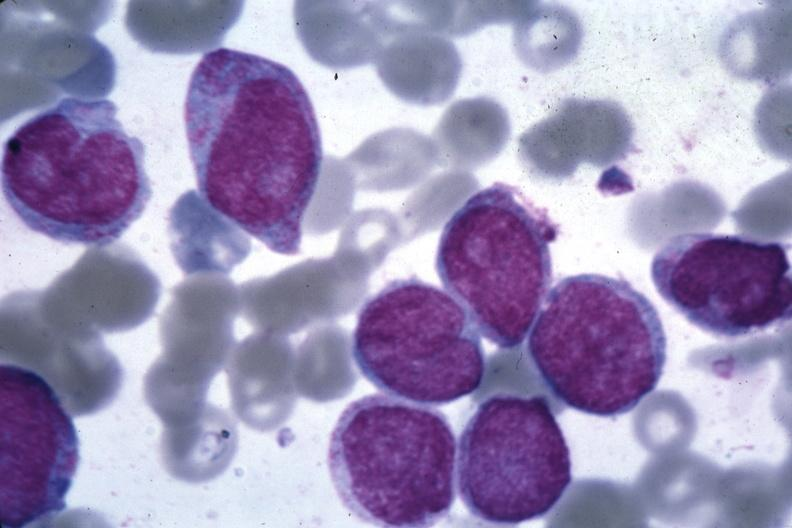what is present?
Answer the question using a single word or phrase. Hematologic 